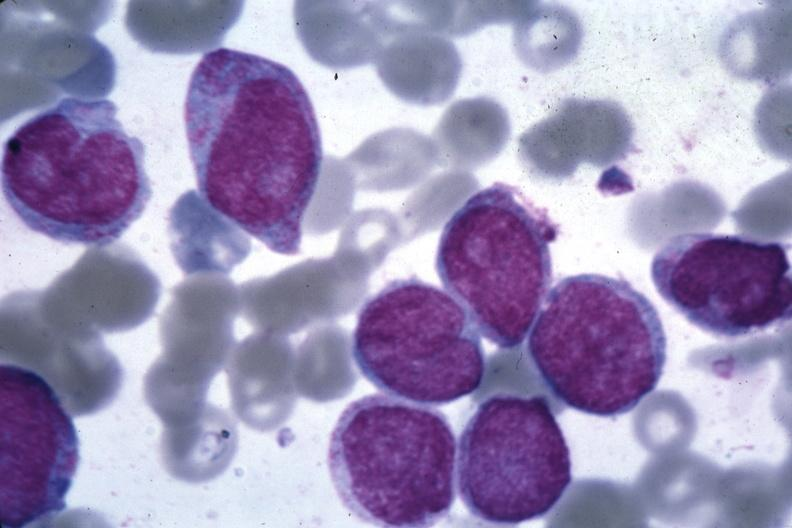what is present?
Answer the question using a single word or phrase. Hematologic 